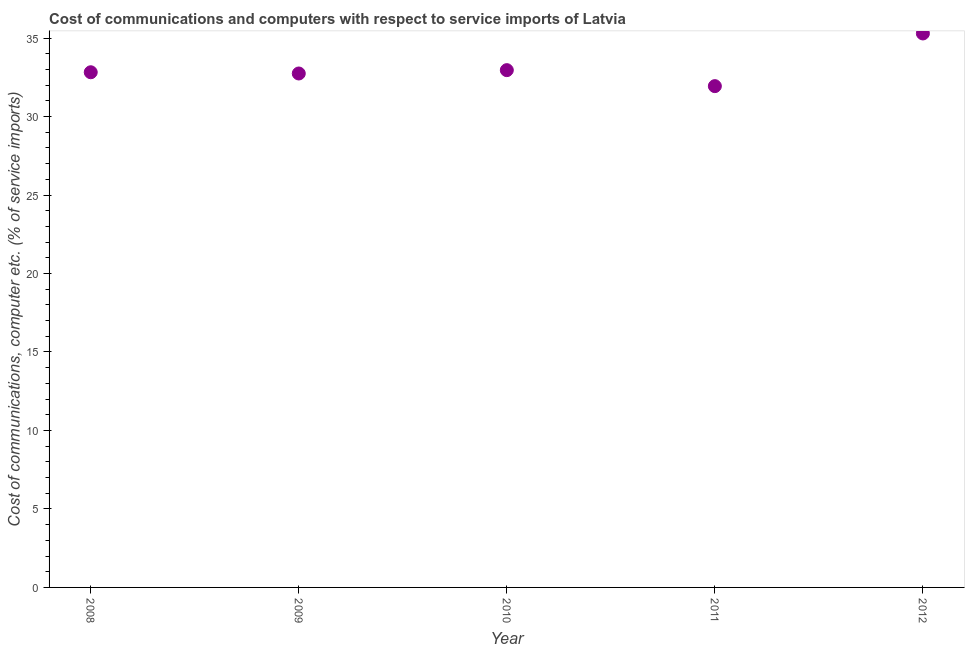What is the cost of communications and computer in 2010?
Provide a short and direct response. 32.95. Across all years, what is the maximum cost of communications and computer?
Ensure brevity in your answer.  35.29. Across all years, what is the minimum cost of communications and computer?
Provide a short and direct response. 31.94. In which year was the cost of communications and computer maximum?
Keep it short and to the point. 2012. In which year was the cost of communications and computer minimum?
Provide a succinct answer. 2011. What is the sum of the cost of communications and computer?
Provide a succinct answer. 165.75. What is the difference between the cost of communications and computer in 2010 and 2011?
Ensure brevity in your answer.  1.02. What is the average cost of communications and computer per year?
Give a very brief answer. 33.15. What is the median cost of communications and computer?
Ensure brevity in your answer.  32.82. In how many years, is the cost of communications and computer greater than 28 %?
Make the answer very short. 5. What is the ratio of the cost of communications and computer in 2008 to that in 2009?
Offer a terse response. 1. Is the cost of communications and computer in 2009 less than that in 2011?
Your response must be concise. No. What is the difference between the highest and the second highest cost of communications and computer?
Make the answer very short. 2.34. What is the difference between the highest and the lowest cost of communications and computer?
Offer a terse response. 3.36. In how many years, is the cost of communications and computer greater than the average cost of communications and computer taken over all years?
Provide a short and direct response. 1. How many dotlines are there?
Keep it short and to the point. 1. What is the difference between two consecutive major ticks on the Y-axis?
Offer a terse response. 5. Does the graph contain grids?
Your answer should be compact. No. What is the title of the graph?
Offer a very short reply. Cost of communications and computers with respect to service imports of Latvia. What is the label or title of the X-axis?
Make the answer very short. Year. What is the label or title of the Y-axis?
Your answer should be compact. Cost of communications, computer etc. (% of service imports). What is the Cost of communications, computer etc. (% of service imports) in 2008?
Your answer should be compact. 32.82. What is the Cost of communications, computer etc. (% of service imports) in 2009?
Make the answer very short. 32.74. What is the Cost of communications, computer etc. (% of service imports) in 2010?
Your response must be concise. 32.95. What is the Cost of communications, computer etc. (% of service imports) in 2011?
Give a very brief answer. 31.94. What is the Cost of communications, computer etc. (% of service imports) in 2012?
Your answer should be very brief. 35.29. What is the difference between the Cost of communications, computer etc. (% of service imports) in 2008 and 2009?
Keep it short and to the point. 0.08. What is the difference between the Cost of communications, computer etc. (% of service imports) in 2008 and 2010?
Keep it short and to the point. -0.13. What is the difference between the Cost of communications, computer etc. (% of service imports) in 2008 and 2011?
Your response must be concise. 0.88. What is the difference between the Cost of communications, computer etc. (% of service imports) in 2008 and 2012?
Keep it short and to the point. -2.47. What is the difference between the Cost of communications, computer etc. (% of service imports) in 2009 and 2010?
Your answer should be very brief. -0.21. What is the difference between the Cost of communications, computer etc. (% of service imports) in 2009 and 2011?
Your answer should be compact. 0.81. What is the difference between the Cost of communications, computer etc. (% of service imports) in 2009 and 2012?
Keep it short and to the point. -2.55. What is the difference between the Cost of communications, computer etc. (% of service imports) in 2010 and 2011?
Your response must be concise. 1.02. What is the difference between the Cost of communications, computer etc. (% of service imports) in 2010 and 2012?
Provide a succinct answer. -2.34. What is the difference between the Cost of communications, computer etc. (% of service imports) in 2011 and 2012?
Provide a short and direct response. -3.36. What is the ratio of the Cost of communications, computer etc. (% of service imports) in 2008 to that in 2009?
Offer a terse response. 1. What is the ratio of the Cost of communications, computer etc. (% of service imports) in 2008 to that in 2011?
Provide a short and direct response. 1.03. What is the ratio of the Cost of communications, computer etc. (% of service imports) in 2008 to that in 2012?
Your answer should be very brief. 0.93. What is the ratio of the Cost of communications, computer etc. (% of service imports) in 2009 to that in 2012?
Offer a very short reply. 0.93. What is the ratio of the Cost of communications, computer etc. (% of service imports) in 2010 to that in 2011?
Ensure brevity in your answer.  1.03. What is the ratio of the Cost of communications, computer etc. (% of service imports) in 2010 to that in 2012?
Provide a succinct answer. 0.93. What is the ratio of the Cost of communications, computer etc. (% of service imports) in 2011 to that in 2012?
Keep it short and to the point. 0.91. 